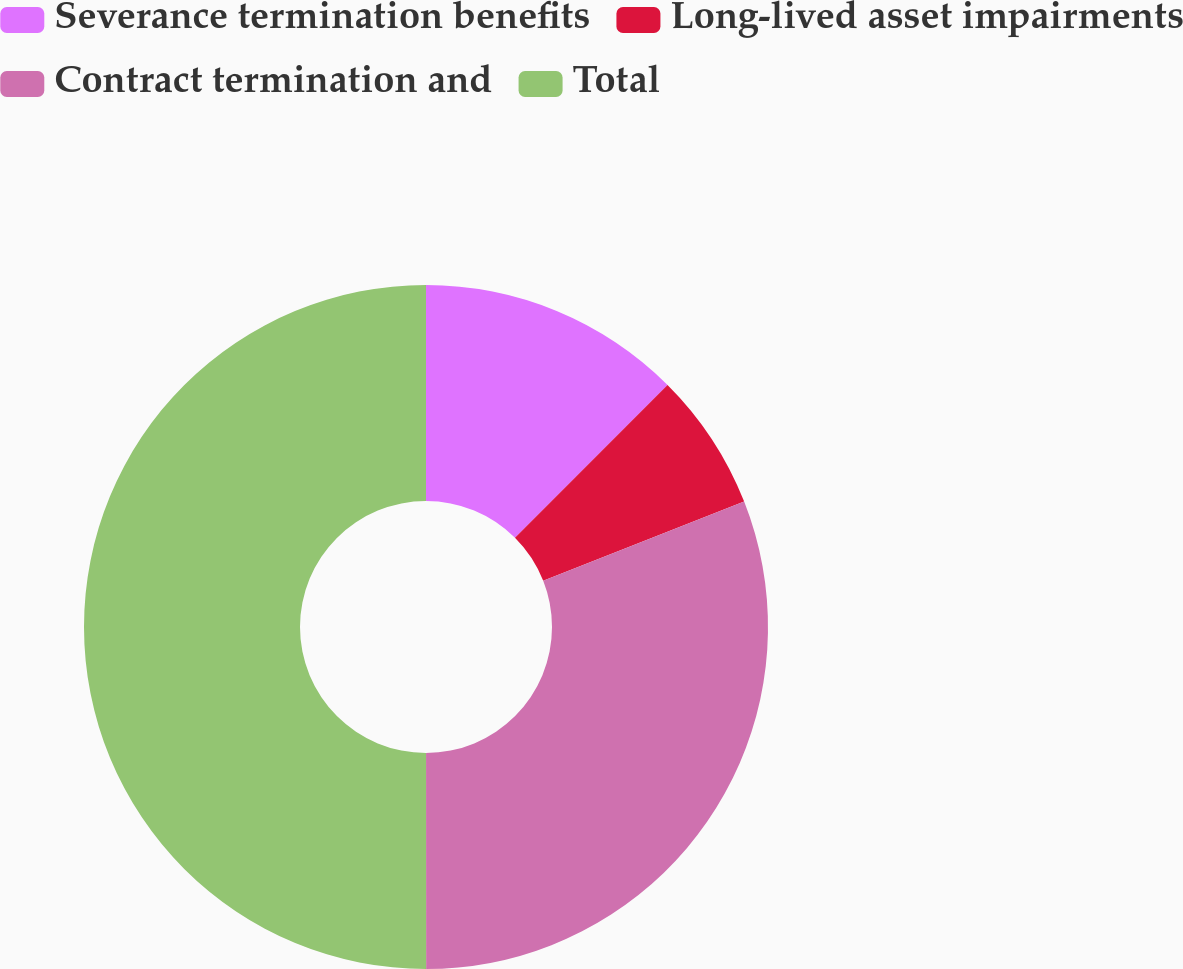Convert chart to OTSL. <chart><loc_0><loc_0><loc_500><loc_500><pie_chart><fcel>Severance termination benefits<fcel>Long-lived asset impairments<fcel>Contract termination and<fcel>Total<nl><fcel>12.48%<fcel>6.54%<fcel>30.97%<fcel>50.0%<nl></chart> 